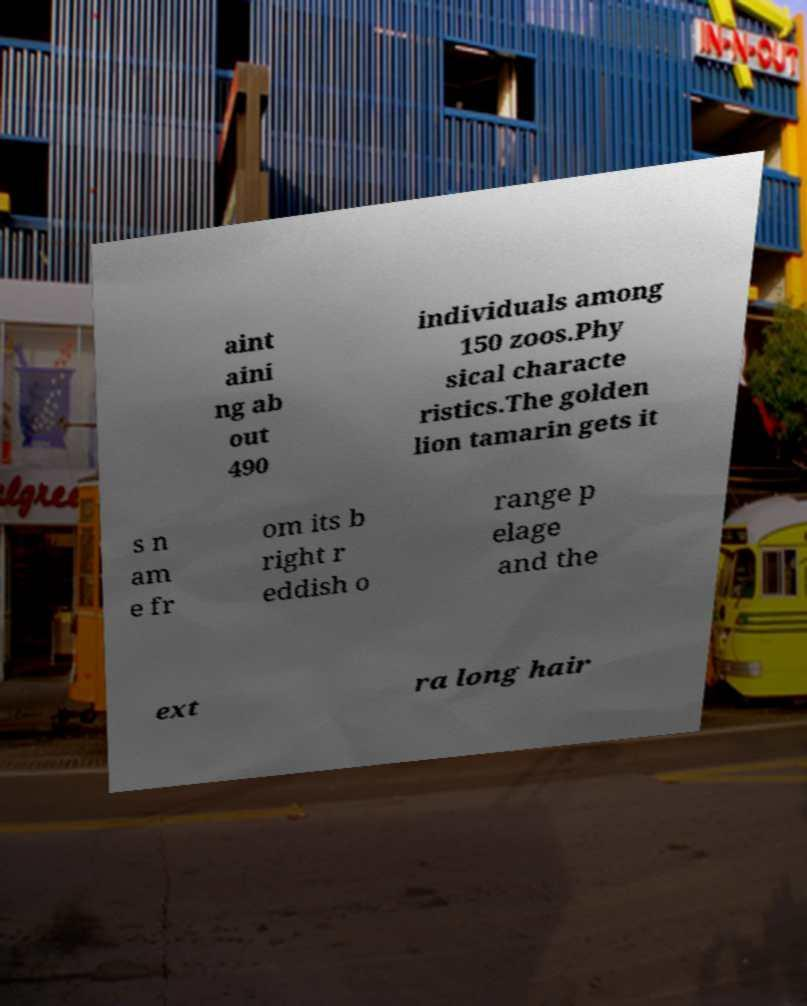Please read and relay the text visible in this image. What does it say? aint aini ng ab out 490 individuals among 150 zoos.Phy sical characte ristics.The golden lion tamarin gets it s n am e fr om its b right r eddish o range p elage and the ext ra long hair 